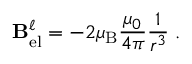<formula> <loc_0><loc_0><loc_500><loc_500>B _ { e l } ^ { \ell } = - 2 \mu _ { B } { \frac { \mu _ { 0 } } { 4 \pi } } { \frac { 1 } { r ^ { 3 } } } \ell .</formula> 